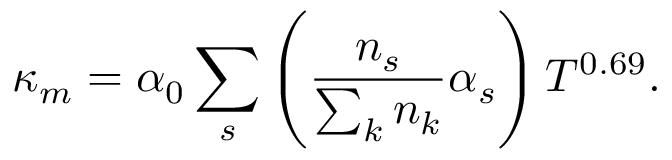<formula> <loc_0><loc_0><loc_500><loc_500>\kappa _ { m } = \alpha _ { 0 } \sum _ { s } \left ( \frac { n _ { s } } { \sum _ { k } n _ { k } } \alpha _ { s } \right ) T ^ { 0 . 6 9 } .</formula> 